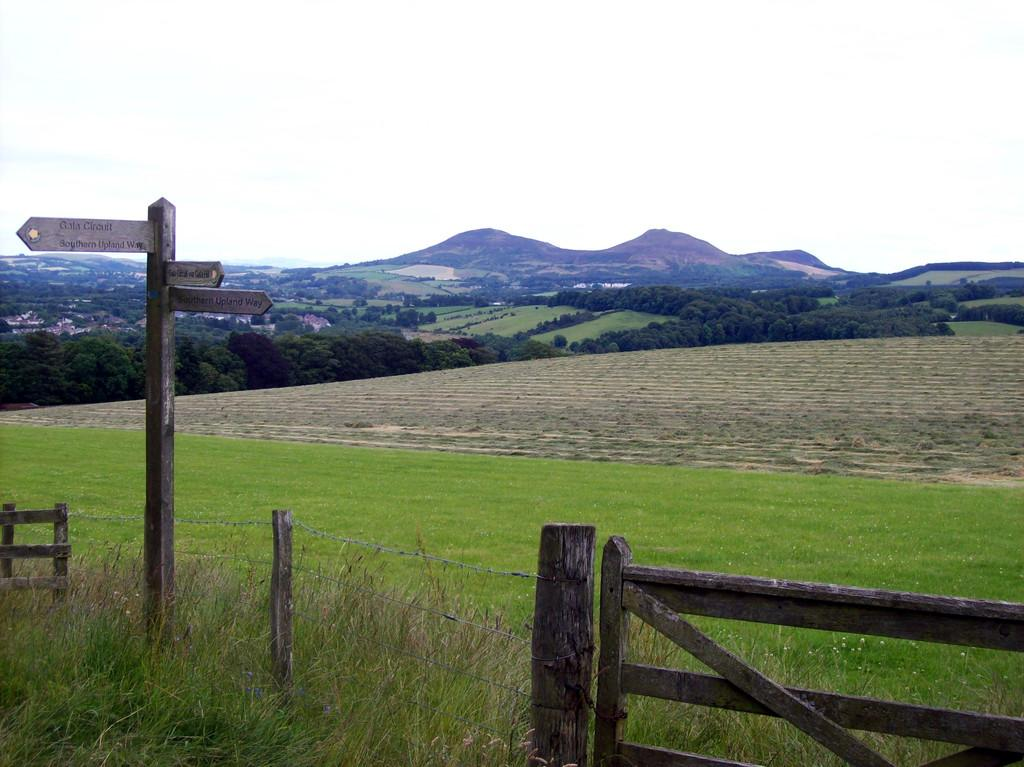What type of fencing can be seen in the image? There is wooden fencing in the image. What is the color of the grass in the image? Green grass is visible in the image. What structures are present in the image that provide information or direction? Sign boards are present in the image. What are the tall, thin structures in the image? Poles are in the image. What type of vegetation can be seen in the image? Trees are in the image. What large landforms are visible in the background of the image? Mountains are visible in the image. What is the color of the sky in the image? The sky appears to be white in color. How many sticks are being used by the coach in the image? There are no sticks or coaches present in the image. What is the desire of the trees in the image? Trees do not have desires; they are inanimate objects. 